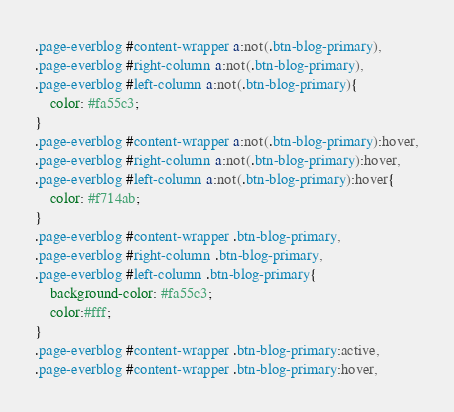<code> <loc_0><loc_0><loc_500><loc_500><_CSS_>.page-everblog #content-wrapper a:not(.btn-blog-primary),
.page-everblog #right-column a:not(.btn-blog-primary),
.page-everblog #left-column a:not(.btn-blog-primary){
    color: #fa55c3;
}
.page-everblog #content-wrapper a:not(.btn-blog-primary):hover,
.page-everblog #right-column a:not(.btn-blog-primary):hover,
.page-everblog #left-column a:not(.btn-blog-primary):hover{
    color: #f714ab;
}
.page-everblog #content-wrapper .btn-blog-primary,
.page-everblog #right-column .btn-blog-primary,
.page-everblog #left-column .btn-blog-primary{
    background-color: #fa55c3;
    color:#fff;
}
.page-everblog #content-wrapper .btn-blog-primary:active,
.page-everblog #content-wrapper .btn-blog-primary:hover,</code> 